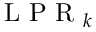<formula> <loc_0><loc_0><loc_500><loc_500>L P R _ { k }</formula> 